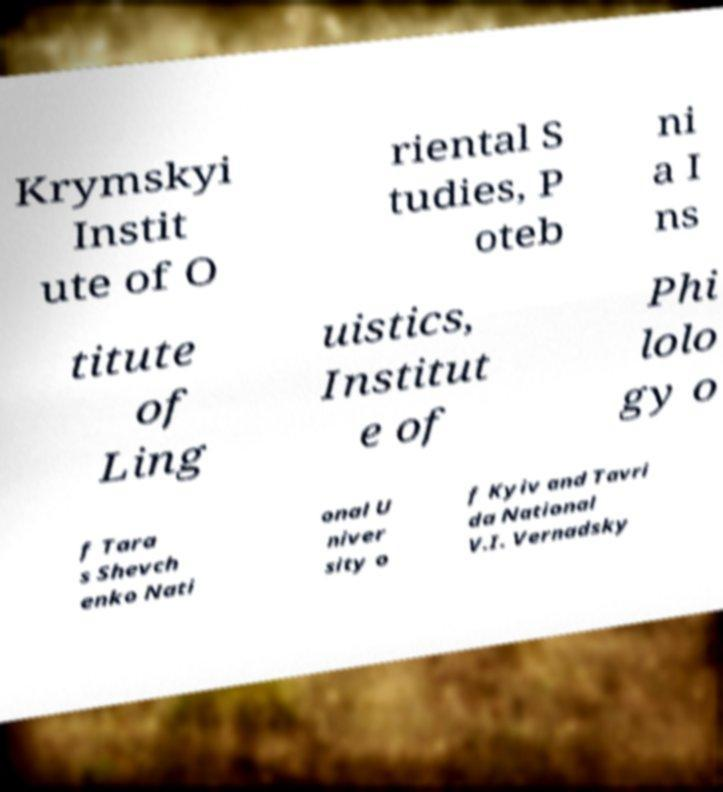Could you extract and type out the text from this image? Krymskyi Instit ute of O riental S tudies, P oteb ni a I ns titute of Ling uistics, Institut e of Phi lolo gy o f Tara s Shevch enko Nati onal U niver sity o f Kyiv and Tavri da National V.I. Vernadsky 